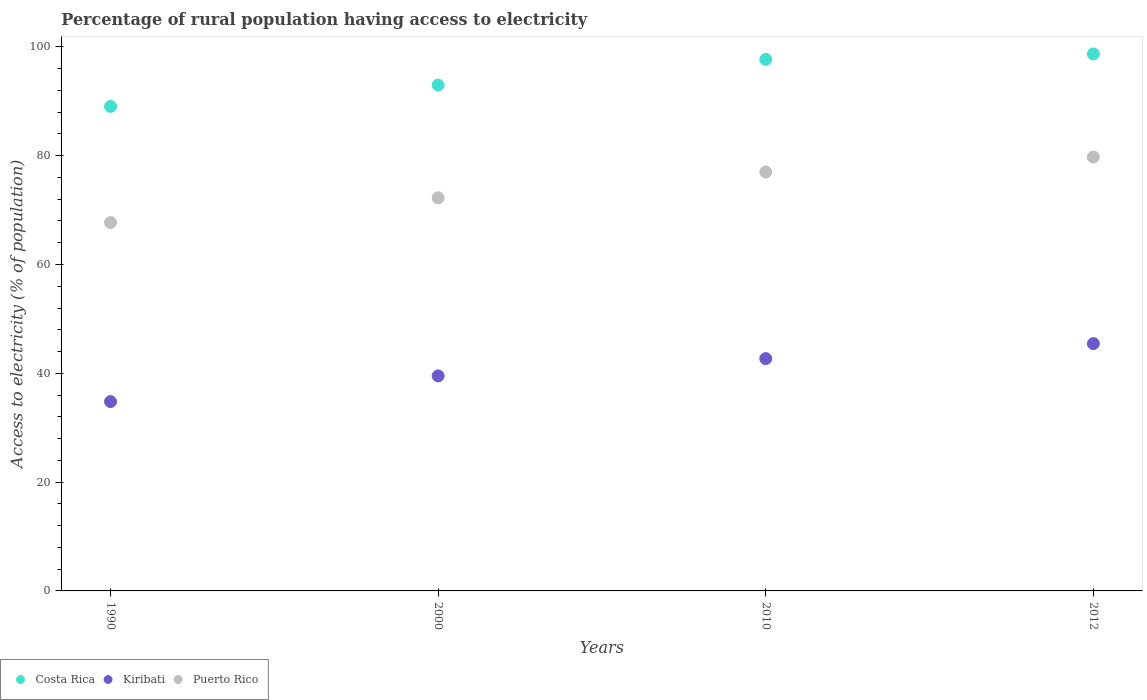How many different coloured dotlines are there?
Offer a terse response. 3. Is the number of dotlines equal to the number of legend labels?
Provide a succinct answer. Yes. What is the percentage of rural population having access to electricity in Kiribati in 2010?
Make the answer very short. 42.7. Across all years, what is the maximum percentage of rural population having access to electricity in Kiribati?
Provide a succinct answer. 45.45. Across all years, what is the minimum percentage of rural population having access to electricity in Kiribati?
Provide a succinct answer. 34.8. In which year was the percentage of rural population having access to electricity in Costa Rica maximum?
Your answer should be compact. 2012. What is the total percentage of rural population having access to electricity in Puerto Rico in the graph?
Provide a short and direct response. 296.73. What is the difference between the percentage of rural population having access to electricity in Kiribati in 2010 and that in 2012?
Make the answer very short. -2.75. What is the difference between the percentage of rural population having access to electricity in Costa Rica in 1990 and the percentage of rural population having access to electricity in Puerto Rico in 2010?
Provide a short and direct response. 12.06. What is the average percentage of rural population having access to electricity in Kiribati per year?
Your response must be concise. 40.62. In the year 2010, what is the difference between the percentage of rural population having access to electricity in Costa Rica and percentage of rural population having access to electricity in Kiribati?
Your answer should be compact. 55. What is the ratio of the percentage of rural population having access to electricity in Kiribati in 2010 to that in 2012?
Your response must be concise. 0.94. Is the difference between the percentage of rural population having access to electricity in Costa Rica in 1990 and 2012 greater than the difference between the percentage of rural population having access to electricity in Kiribati in 1990 and 2012?
Your answer should be compact. Yes. What is the difference between the highest and the second highest percentage of rural population having access to electricity in Costa Rica?
Your answer should be very brief. 1. What is the difference between the highest and the lowest percentage of rural population having access to electricity in Puerto Rico?
Provide a short and direct response. 12.04. In how many years, is the percentage of rural population having access to electricity in Costa Rica greater than the average percentage of rural population having access to electricity in Costa Rica taken over all years?
Your answer should be compact. 2. Is it the case that in every year, the sum of the percentage of rural population having access to electricity in Puerto Rico and percentage of rural population having access to electricity in Costa Rica  is greater than the percentage of rural population having access to electricity in Kiribati?
Provide a short and direct response. Yes. Is the percentage of rural population having access to electricity in Puerto Rico strictly greater than the percentage of rural population having access to electricity in Costa Rica over the years?
Give a very brief answer. No. Is the percentage of rural population having access to electricity in Puerto Rico strictly less than the percentage of rural population having access to electricity in Costa Rica over the years?
Give a very brief answer. Yes. How many dotlines are there?
Keep it short and to the point. 3. What is the difference between two consecutive major ticks on the Y-axis?
Your answer should be very brief. 20. Are the values on the major ticks of Y-axis written in scientific E-notation?
Make the answer very short. No. How many legend labels are there?
Keep it short and to the point. 3. What is the title of the graph?
Make the answer very short. Percentage of rural population having access to electricity. What is the label or title of the X-axis?
Offer a terse response. Years. What is the label or title of the Y-axis?
Provide a short and direct response. Access to electricity (% of population). What is the Access to electricity (% of population) of Costa Rica in 1990?
Your response must be concise. 89.06. What is the Access to electricity (% of population) in Kiribati in 1990?
Make the answer very short. 34.8. What is the Access to electricity (% of population) of Puerto Rico in 1990?
Your answer should be very brief. 67.71. What is the Access to electricity (% of population) in Costa Rica in 2000?
Your answer should be very brief. 92.98. What is the Access to electricity (% of population) in Kiribati in 2000?
Make the answer very short. 39.52. What is the Access to electricity (% of population) in Puerto Rico in 2000?
Give a very brief answer. 72.27. What is the Access to electricity (% of population) in Costa Rica in 2010?
Offer a very short reply. 97.7. What is the Access to electricity (% of population) in Kiribati in 2010?
Your answer should be compact. 42.7. What is the Access to electricity (% of population) in Puerto Rico in 2010?
Your answer should be compact. 77. What is the Access to electricity (% of population) of Costa Rica in 2012?
Ensure brevity in your answer.  98.7. What is the Access to electricity (% of population) of Kiribati in 2012?
Keep it short and to the point. 45.45. What is the Access to electricity (% of population) of Puerto Rico in 2012?
Offer a very short reply. 79.75. Across all years, what is the maximum Access to electricity (% of population) in Costa Rica?
Provide a short and direct response. 98.7. Across all years, what is the maximum Access to electricity (% of population) of Kiribati?
Keep it short and to the point. 45.45. Across all years, what is the maximum Access to electricity (% of population) in Puerto Rico?
Make the answer very short. 79.75. Across all years, what is the minimum Access to electricity (% of population) in Costa Rica?
Ensure brevity in your answer.  89.06. Across all years, what is the minimum Access to electricity (% of population) in Kiribati?
Provide a succinct answer. 34.8. Across all years, what is the minimum Access to electricity (% of population) in Puerto Rico?
Provide a succinct answer. 67.71. What is the total Access to electricity (% of population) of Costa Rica in the graph?
Your answer should be compact. 378.44. What is the total Access to electricity (% of population) of Kiribati in the graph?
Keep it short and to the point. 162.47. What is the total Access to electricity (% of population) in Puerto Rico in the graph?
Offer a very short reply. 296.73. What is the difference between the Access to electricity (% of population) of Costa Rica in 1990 and that in 2000?
Give a very brief answer. -3.92. What is the difference between the Access to electricity (% of population) of Kiribati in 1990 and that in 2000?
Ensure brevity in your answer.  -4.72. What is the difference between the Access to electricity (% of population) of Puerto Rico in 1990 and that in 2000?
Provide a short and direct response. -4.55. What is the difference between the Access to electricity (% of population) of Costa Rica in 1990 and that in 2010?
Your answer should be very brief. -8.64. What is the difference between the Access to electricity (% of population) of Kiribati in 1990 and that in 2010?
Your answer should be compact. -7.9. What is the difference between the Access to electricity (% of population) of Puerto Rico in 1990 and that in 2010?
Ensure brevity in your answer.  -9.29. What is the difference between the Access to electricity (% of population) of Costa Rica in 1990 and that in 2012?
Your response must be concise. -9.64. What is the difference between the Access to electricity (% of population) in Kiribati in 1990 and that in 2012?
Make the answer very short. -10.66. What is the difference between the Access to electricity (% of population) in Puerto Rico in 1990 and that in 2012?
Offer a terse response. -12.04. What is the difference between the Access to electricity (% of population) of Costa Rica in 2000 and that in 2010?
Give a very brief answer. -4.72. What is the difference between the Access to electricity (% of population) in Kiribati in 2000 and that in 2010?
Your answer should be compact. -3.18. What is the difference between the Access to electricity (% of population) of Puerto Rico in 2000 and that in 2010?
Keep it short and to the point. -4.74. What is the difference between the Access to electricity (% of population) in Costa Rica in 2000 and that in 2012?
Offer a very short reply. -5.72. What is the difference between the Access to electricity (% of population) of Kiribati in 2000 and that in 2012?
Make the answer very short. -5.93. What is the difference between the Access to electricity (% of population) in Puerto Rico in 2000 and that in 2012?
Ensure brevity in your answer.  -7.49. What is the difference between the Access to electricity (% of population) in Costa Rica in 2010 and that in 2012?
Your answer should be compact. -1. What is the difference between the Access to electricity (% of population) in Kiribati in 2010 and that in 2012?
Your response must be concise. -2.75. What is the difference between the Access to electricity (% of population) in Puerto Rico in 2010 and that in 2012?
Provide a short and direct response. -2.75. What is the difference between the Access to electricity (% of population) of Costa Rica in 1990 and the Access to electricity (% of population) of Kiribati in 2000?
Your answer should be compact. 49.54. What is the difference between the Access to electricity (% of population) in Costa Rica in 1990 and the Access to electricity (% of population) in Puerto Rico in 2000?
Your answer should be compact. 16.8. What is the difference between the Access to electricity (% of population) of Kiribati in 1990 and the Access to electricity (% of population) of Puerto Rico in 2000?
Offer a terse response. -37.47. What is the difference between the Access to electricity (% of population) in Costa Rica in 1990 and the Access to electricity (% of population) in Kiribati in 2010?
Your answer should be very brief. 46.36. What is the difference between the Access to electricity (% of population) of Costa Rica in 1990 and the Access to electricity (% of population) of Puerto Rico in 2010?
Provide a succinct answer. 12.06. What is the difference between the Access to electricity (% of population) in Kiribati in 1990 and the Access to electricity (% of population) in Puerto Rico in 2010?
Offer a very short reply. -42.2. What is the difference between the Access to electricity (% of population) of Costa Rica in 1990 and the Access to electricity (% of population) of Kiribati in 2012?
Provide a succinct answer. 43.61. What is the difference between the Access to electricity (% of population) in Costa Rica in 1990 and the Access to electricity (% of population) in Puerto Rico in 2012?
Keep it short and to the point. 9.31. What is the difference between the Access to electricity (% of population) in Kiribati in 1990 and the Access to electricity (% of population) in Puerto Rico in 2012?
Provide a short and direct response. -44.96. What is the difference between the Access to electricity (% of population) of Costa Rica in 2000 and the Access to electricity (% of population) of Kiribati in 2010?
Keep it short and to the point. 50.28. What is the difference between the Access to electricity (% of population) in Costa Rica in 2000 and the Access to electricity (% of population) in Puerto Rico in 2010?
Offer a terse response. 15.98. What is the difference between the Access to electricity (% of population) of Kiribati in 2000 and the Access to electricity (% of population) of Puerto Rico in 2010?
Provide a short and direct response. -37.48. What is the difference between the Access to electricity (% of population) of Costa Rica in 2000 and the Access to electricity (% of population) of Kiribati in 2012?
Provide a succinct answer. 47.53. What is the difference between the Access to electricity (% of population) of Costa Rica in 2000 and the Access to electricity (% of population) of Puerto Rico in 2012?
Offer a terse response. 13.23. What is the difference between the Access to electricity (% of population) of Kiribati in 2000 and the Access to electricity (% of population) of Puerto Rico in 2012?
Provide a succinct answer. -40.23. What is the difference between the Access to electricity (% of population) in Costa Rica in 2010 and the Access to electricity (% of population) in Kiribati in 2012?
Ensure brevity in your answer.  52.25. What is the difference between the Access to electricity (% of population) of Costa Rica in 2010 and the Access to electricity (% of population) of Puerto Rico in 2012?
Provide a short and direct response. 17.95. What is the difference between the Access to electricity (% of population) of Kiribati in 2010 and the Access to electricity (% of population) of Puerto Rico in 2012?
Your answer should be compact. -37.05. What is the average Access to electricity (% of population) in Costa Rica per year?
Offer a very short reply. 94.61. What is the average Access to electricity (% of population) in Kiribati per year?
Provide a short and direct response. 40.62. What is the average Access to electricity (% of population) in Puerto Rico per year?
Your answer should be compact. 74.18. In the year 1990, what is the difference between the Access to electricity (% of population) in Costa Rica and Access to electricity (% of population) in Kiribati?
Your answer should be very brief. 54.26. In the year 1990, what is the difference between the Access to electricity (% of population) in Costa Rica and Access to electricity (% of population) in Puerto Rico?
Your answer should be compact. 21.35. In the year 1990, what is the difference between the Access to electricity (% of population) in Kiribati and Access to electricity (% of population) in Puerto Rico?
Offer a very short reply. -32.91. In the year 2000, what is the difference between the Access to electricity (% of population) in Costa Rica and Access to electricity (% of population) in Kiribati?
Your response must be concise. 53.46. In the year 2000, what is the difference between the Access to electricity (% of population) in Costa Rica and Access to electricity (% of population) in Puerto Rico?
Offer a terse response. 20.72. In the year 2000, what is the difference between the Access to electricity (% of population) of Kiribati and Access to electricity (% of population) of Puerto Rico?
Provide a succinct answer. -32.74. In the year 2010, what is the difference between the Access to electricity (% of population) in Costa Rica and Access to electricity (% of population) in Kiribati?
Provide a succinct answer. 55. In the year 2010, what is the difference between the Access to electricity (% of population) of Costa Rica and Access to electricity (% of population) of Puerto Rico?
Your answer should be compact. 20.7. In the year 2010, what is the difference between the Access to electricity (% of population) in Kiribati and Access to electricity (% of population) in Puerto Rico?
Offer a very short reply. -34.3. In the year 2012, what is the difference between the Access to electricity (% of population) in Costa Rica and Access to electricity (% of population) in Kiribati?
Give a very brief answer. 53.25. In the year 2012, what is the difference between the Access to electricity (% of population) of Costa Rica and Access to electricity (% of population) of Puerto Rico?
Provide a succinct answer. 18.95. In the year 2012, what is the difference between the Access to electricity (% of population) of Kiribati and Access to electricity (% of population) of Puerto Rico?
Give a very brief answer. -34.3. What is the ratio of the Access to electricity (% of population) in Costa Rica in 1990 to that in 2000?
Keep it short and to the point. 0.96. What is the ratio of the Access to electricity (% of population) of Kiribati in 1990 to that in 2000?
Provide a short and direct response. 0.88. What is the ratio of the Access to electricity (% of population) of Puerto Rico in 1990 to that in 2000?
Keep it short and to the point. 0.94. What is the ratio of the Access to electricity (% of population) of Costa Rica in 1990 to that in 2010?
Your answer should be very brief. 0.91. What is the ratio of the Access to electricity (% of population) in Kiribati in 1990 to that in 2010?
Keep it short and to the point. 0.81. What is the ratio of the Access to electricity (% of population) of Puerto Rico in 1990 to that in 2010?
Make the answer very short. 0.88. What is the ratio of the Access to electricity (% of population) of Costa Rica in 1990 to that in 2012?
Your response must be concise. 0.9. What is the ratio of the Access to electricity (% of population) in Kiribati in 1990 to that in 2012?
Provide a short and direct response. 0.77. What is the ratio of the Access to electricity (% of population) of Puerto Rico in 1990 to that in 2012?
Provide a short and direct response. 0.85. What is the ratio of the Access to electricity (% of population) of Costa Rica in 2000 to that in 2010?
Your answer should be very brief. 0.95. What is the ratio of the Access to electricity (% of population) in Kiribati in 2000 to that in 2010?
Make the answer very short. 0.93. What is the ratio of the Access to electricity (% of population) in Puerto Rico in 2000 to that in 2010?
Your response must be concise. 0.94. What is the ratio of the Access to electricity (% of population) in Costa Rica in 2000 to that in 2012?
Your response must be concise. 0.94. What is the ratio of the Access to electricity (% of population) of Kiribati in 2000 to that in 2012?
Your answer should be compact. 0.87. What is the ratio of the Access to electricity (% of population) of Puerto Rico in 2000 to that in 2012?
Keep it short and to the point. 0.91. What is the ratio of the Access to electricity (% of population) in Costa Rica in 2010 to that in 2012?
Your response must be concise. 0.99. What is the ratio of the Access to electricity (% of population) in Kiribati in 2010 to that in 2012?
Offer a terse response. 0.94. What is the ratio of the Access to electricity (% of population) of Puerto Rico in 2010 to that in 2012?
Give a very brief answer. 0.97. What is the difference between the highest and the second highest Access to electricity (% of population) in Kiribati?
Provide a short and direct response. 2.75. What is the difference between the highest and the second highest Access to electricity (% of population) in Puerto Rico?
Provide a short and direct response. 2.75. What is the difference between the highest and the lowest Access to electricity (% of population) of Costa Rica?
Give a very brief answer. 9.64. What is the difference between the highest and the lowest Access to electricity (% of population) of Kiribati?
Provide a short and direct response. 10.66. What is the difference between the highest and the lowest Access to electricity (% of population) of Puerto Rico?
Your response must be concise. 12.04. 